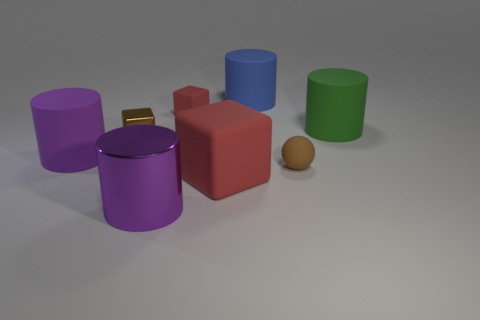Add 2 big brown shiny spheres. How many objects exist? 10 Subtract all purple cylinders. How many cylinders are left? 2 Subtract all matte blocks. How many blocks are left? 1 Subtract all blocks. How many objects are left? 5 Subtract 1 cylinders. How many cylinders are left? 3 Subtract all green cylinders. How many red cubes are left? 2 Subtract all large red rubber blocks. Subtract all green matte cylinders. How many objects are left? 6 Add 4 tiny things. How many tiny things are left? 7 Add 1 large blocks. How many large blocks exist? 2 Subtract 1 blue cylinders. How many objects are left? 7 